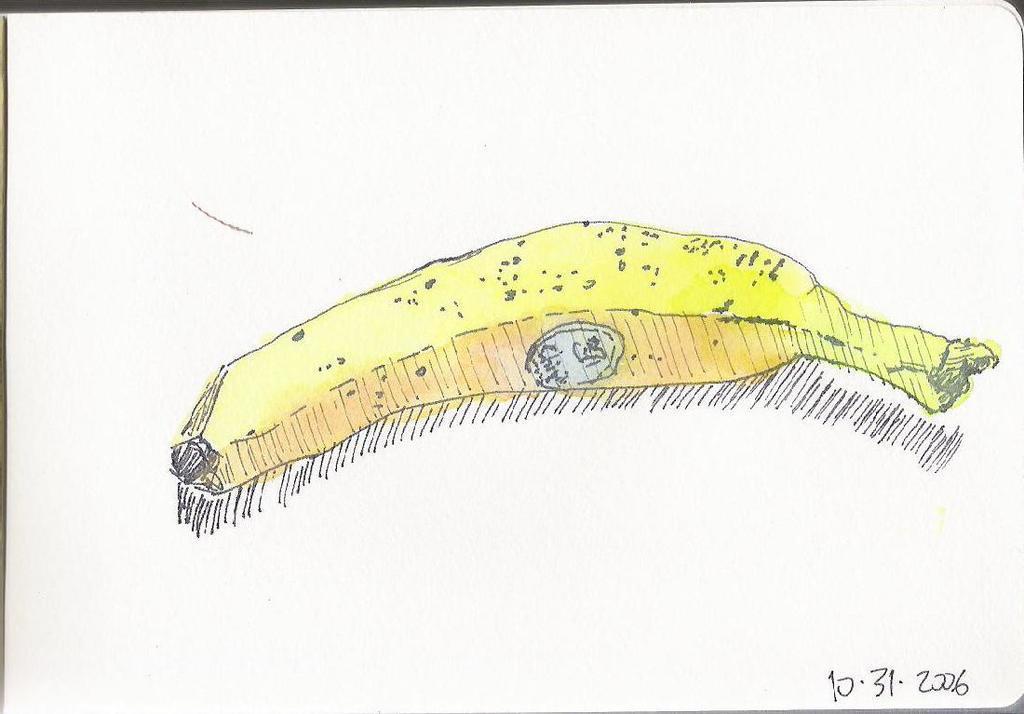Could you give a brief overview of what you see in this image? In this image there is a sketch of a banana. Below the sketch there are lines. In the bottom right there are numbers on the image. The background is white. 